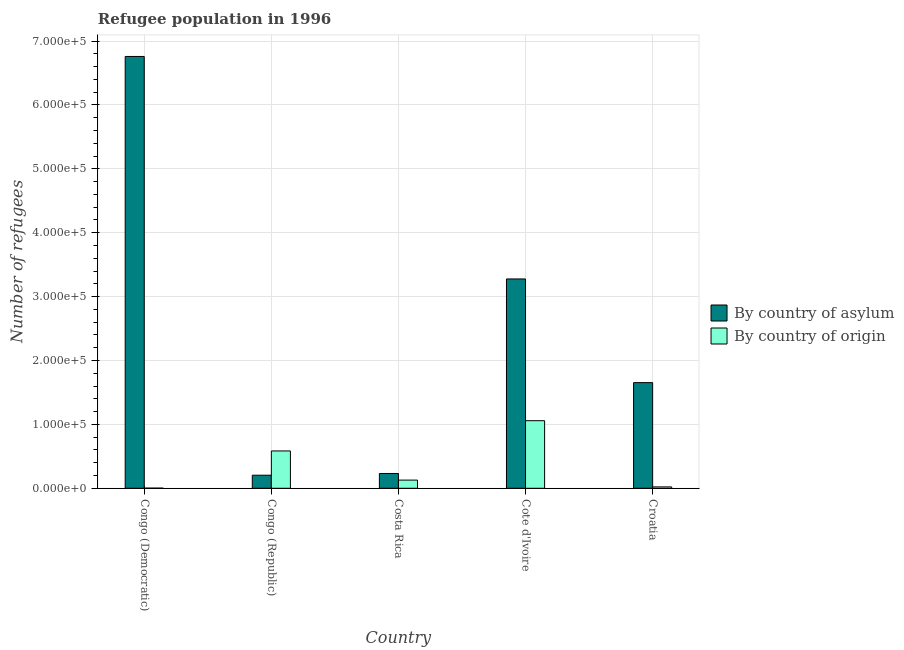How many groups of bars are there?
Offer a very short reply. 5. Are the number of bars on each tick of the X-axis equal?
Make the answer very short. Yes. How many bars are there on the 5th tick from the left?
Provide a short and direct response. 2. How many bars are there on the 1st tick from the right?
Offer a terse response. 2. What is the label of the 1st group of bars from the left?
Ensure brevity in your answer.  Congo (Democratic). In how many cases, is the number of bars for a given country not equal to the number of legend labels?
Give a very brief answer. 0. What is the number of refugees by country of asylum in Costa Rica?
Your response must be concise. 2.32e+04. Across all countries, what is the maximum number of refugees by country of origin?
Give a very brief answer. 1.06e+05. Across all countries, what is the minimum number of refugees by country of origin?
Offer a terse response. 240. In which country was the number of refugees by country of asylum maximum?
Give a very brief answer. Congo (Democratic). In which country was the number of refugees by country of origin minimum?
Keep it short and to the point. Congo (Democratic). What is the total number of refugees by country of asylum in the graph?
Your answer should be very brief. 1.21e+06. What is the difference between the number of refugees by country of origin in Congo (Republic) and that in Croatia?
Ensure brevity in your answer.  5.63e+04. What is the difference between the number of refugees by country of asylum in Congo (Republic) and the number of refugees by country of origin in Cote d'Ivoire?
Provide a succinct answer. -8.54e+04. What is the average number of refugees by country of origin per country?
Make the answer very short. 3.59e+04. What is the difference between the number of refugees by country of asylum and number of refugees by country of origin in Croatia?
Your answer should be compact. 1.63e+05. In how many countries, is the number of refugees by country of asylum greater than 300000 ?
Provide a short and direct response. 2. What is the ratio of the number of refugees by country of origin in Congo (Republic) to that in Croatia?
Offer a terse response. 26.96. Is the number of refugees by country of asylum in Congo (Democratic) less than that in Cote d'Ivoire?
Ensure brevity in your answer.  No. What is the difference between the highest and the second highest number of refugees by country of origin?
Offer a terse response. 4.74e+04. What is the difference between the highest and the lowest number of refugees by country of asylum?
Provide a succinct answer. 6.56e+05. In how many countries, is the number of refugees by country of origin greater than the average number of refugees by country of origin taken over all countries?
Offer a very short reply. 2. Is the sum of the number of refugees by country of origin in Congo (Democratic) and Congo (Republic) greater than the maximum number of refugees by country of asylum across all countries?
Make the answer very short. No. What does the 2nd bar from the left in Congo (Republic) represents?
Make the answer very short. By country of origin. What does the 2nd bar from the right in Croatia represents?
Ensure brevity in your answer.  By country of asylum. What is the difference between two consecutive major ticks on the Y-axis?
Give a very brief answer. 1.00e+05. How are the legend labels stacked?
Your answer should be very brief. Vertical. What is the title of the graph?
Make the answer very short. Refugee population in 1996. Does "Adolescent fertility rate" appear as one of the legend labels in the graph?
Provide a short and direct response. No. What is the label or title of the X-axis?
Your answer should be very brief. Country. What is the label or title of the Y-axis?
Ensure brevity in your answer.  Number of refugees. What is the Number of refugees in By country of asylum in Congo (Democratic)?
Offer a terse response. 6.76e+05. What is the Number of refugees in By country of origin in Congo (Democratic)?
Your answer should be very brief. 240. What is the Number of refugees in By country of asylum in Congo (Republic)?
Make the answer very short. 2.05e+04. What is the Number of refugees of By country of origin in Congo (Republic)?
Keep it short and to the point. 5.84e+04. What is the Number of refugees of By country of asylum in Costa Rica?
Provide a short and direct response. 2.32e+04. What is the Number of refugees of By country of origin in Costa Rica?
Offer a very short reply. 1.28e+04. What is the Number of refugees in By country of asylum in Cote d'Ivoire?
Provide a short and direct response. 3.28e+05. What is the Number of refugees in By country of origin in Cote d'Ivoire?
Your answer should be very brief. 1.06e+05. What is the Number of refugees of By country of asylum in Croatia?
Offer a very short reply. 1.65e+05. What is the Number of refugees of By country of origin in Croatia?
Offer a terse response. 2168. Across all countries, what is the maximum Number of refugees in By country of asylum?
Ensure brevity in your answer.  6.76e+05. Across all countries, what is the maximum Number of refugees of By country of origin?
Provide a short and direct response. 1.06e+05. Across all countries, what is the minimum Number of refugees of By country of asylum?
Offer a very short reply. 2.05e+04. Across all countries, what is the minimum Number of refugees in By country of origin?
Your answer should be compact. 240. What is the total Number of refugees in By country of asylum in the graph?
Give a very brief answer. 1.21e+06. What is the total Number of refugees in By country of origin in the graph?
Give a very brief answer. 1.79e+05. What is the difference between the Number of refugees in By country of asylum in Congo (Democratic) and that in Congo (Republic)?
Your answer should be compact. 6.56e+05. What is the difference between the Number of refugees of By country of origin in Congo (Democratic) and that in Congo (Republic)?
Your answer should be compact. -5.82e+04. What is the difference between the Number of refugees in By country of asylum in Congo (Democratic) and that in Costa Rica?
Ensure brevity in your answer.  6.53e+05. What is the difference between the Number of refugees in By country of origin in Congo (Democratic) and that in Costa Rica?
Your answer should be compact. -1.26e+04. What is the difference between the Number of refugees in By country of asylum in Congo (Democratic) and that in Cote d'Ivoire?
Provide a succinct answer. 3.48e+05. What is the difference between the Number of refugees in By country of origin in Congo (Democratic) and that in Cote d'Ivoire?
Ensure brevity in your answer.  -1.06e+05. What is the difference between the Number of refugees in By country of asylum in Congo (Democratic) and that in Croatia?
Your answer should be compact. 5.11e+05. What is the difference between the Number of refugees in By country of origin in Congo (Democratic) and that in Croatia?
Your response must be concise. -1928. What is the difference between the Number of refugees in By country of asylum in Congo (Republic) and that in Costa Rica?
Your answer should be very brief. -2725. What is the difference between the Number of refugees in By country of origin in Congo (Republic) and that in Costa Rica?
Ensure brevity in your answer.  4.56e+04. What is the difference between the Number of refugees in By country of asylum in Congo (Republic) and that in Cote d'Ivoire?
Make the answer very short. -3.07e+05. What is the difference between the Number of refugees in By country of origin in Congo (Republic) and that in Cote d'Ivoire?
Your response must be concise. -4.74e+04. What is the difference between the Number of refugees in By country of asylum in Congo (Republic) and that in Croatia?
Your answer should be compact. -1.45e+05. What is the difference between the Number of refugees in By country of origin in Congo (Republic) and that in Croatia?
Your answer should be compact. 5.63e+04. What is the difference between the Number of refugees of By country of asylum in Costa Rica and that in Cote d'Ivoire?
Provide a succinct answer. -3.05e+05. What is the difference between the Number of refugees of By country of origin in Costa Rica and that in Cote d'Ivoire?
Ensure brevity in your answer.  -9.30e+04. What is the difference between the Number of refugees in By country of asylum in Costa Rica and that in Croatia?
Offer a very short reply. -1.42e+05. What is the difference between the Number of refugees in By country of origin in Costa Rica and that in Croatia?
Offer a terse response. 1.06e+04. What is the difference between the Number of refugees of By country of asylum in Cote d'Ivoire and that in Croatia?
Offer a very short reply. 1.62e+05. What is the difference between the Number of refugees of By country of origin in Cote d'Ivoire and that in Croatia?
Ensure brevity in your answer.  1.04e+05. What is the difference between the Number of refugees of By country of asylum in Congo (Democratic) and the Number of refugees of By country of origin in Congo (Republic)?
Give a very brief answer. 6.18e+05. What is the difference between the Number of refugees of By country of asylum in Congo (Democratic) and the Number of refugees of By country of origin in Costa Rica?
Keep it short and to the point. 6.63e+05. What is the difference between the Number of refugees of By country of asylum in Congo (Democratic) and the Number of refugees of By country of origin in Cote d'Ivoire?
Your response must be concise. 5.70e+05. What is the difference between the Number of refugees in By country of asylum in Congo (Democratic) and the Number of refugees in By country of origin in Croatia?
Offer a terse response. 6.74e+05. What is the difference between the Number of refugees of By country of asylum in Congo (Republic) and the Number of refugees of By country of origin in Costa Rica?
Ensure brevity in your answer.  7646. What is the difference between the Number of refugees in By country of asylum in Congo (Republic) and the Number of refugees in By country of origin in Cote d'Ivoire?
Your answer should be compact. -8.54e+04. What is the difference between the Number of refugees in By country of asylum in Congo (Republic) and the Number of refugees in By country of origin in Croatia?
Offer a very short reply. 1.83e+04. What is the difference between the Number of refugees in By country of asylum in Costa Rica and the Number of refugees in By country of origin in Cote d'Ivoire?
Offer a very short reply. -8.26e+04. What is the difference between the Number of refugees of By country of asylum in Costa Rica and the Number of refugees of By country of origin in Croatia?
Keep it short and to the point. 2.10e+04. What is the difference between the Number of refugees of By country of asylum in Cote d'Ivoire and the Number of refugees of By country of origin in Croatia?
Make the answer very short. 3.26e+05. What is the average Number of refugees of By country of asylum per country?
Your answer should be compact. 2.43e+05. What is the average Number of refugees of By country of origin per country?
Make the answer very short. 3.59e+04. What is the difference between the Number of refugees of By country of asylum and Number of refugees of By country of origin in Congo (Democratic)?
Give a very brief answer. 6.76e+05. What is the difference between the Number of refugees in By country of asylum and Number of refugees in By country of origin in Congo (Republic)?
Your response must be concise. -3.80e+04. What is the difference between the Number of refugees of By country of asylum and Number of refugees of By country of origin in Costa Rica?
Your answer should be very brief. 1.04e+04. What is the difference between the Number of refugees of By country of asylum and Number of refugees of By country of origin in Cote d'Ivoire?
Provide a succinct answer. 2.22e+05. What is the difference between the Number of refugees of By country of asylum and Number of refugees of By country of origin in Croatia?
Ensure brevity in your answer.  1.63e+05. What is the ratio of the Number of refugees in By country of asylum in Congo (Democratic) to that in Congo (Republic)?
Provide a succinct answer. 33.05. What is the ratio of the Number of refugees of By country of origin in Congo (Democratic) to that in Congo (Republic)?
Your answer should be very brief. 0. What is the ratio of the Number of refugees in By country of asylum in Congo (Democratic) to that in Costa Rica?
Provide a short and direct response. 29.17. What is the ratio of the Number of refugees of By country of origin in Congo (Democratic) to that in Costa Rica?
Make the answer very short. 0.02. What is the ratio of the Number of refugees of By country of asylum in Congo (Democratic) to that in Cote d'Ivoire?
Offer a very short reply. 2.06. What is the ratio of the Number of refugees of By country of origin in Congo (Democratic) to that in Cote d'Ivoire?
Your answer should be very brief. 0. What is the ratio of the Number of refugees in By country of asylum in Congo (Democratic) to that in Croatia?
Your answer should be compact. 4.09. What is the ratio of the Number of refugees in By country of origin in Congo (Democratic) to that in Croatia?
Make the answer very short. 0.11. What is the ratio of the Number of refugees in By country of asylum in Congo (Republic) to that in Costa Rica?
Make the answer very short. 0.88. What is the ratio of the Number of refugees in By country of origin in Congo (Republic) to that in Costa Rica?
Ensure brevity in your answer.  4.56. What is the ratio of the Number of refugees in By country of asylum in Congo (Republic) to that in Cote d'Ivoire?
Give a very brief answer. 0.06. What is the ratio of the Number of refugees of By country of origin in Congo (Republic) to that in Cote d'Ivoire?
Make the answer very short. 0.55. What is the ratio of the Number of refugees of By country of asylum in Congo (Republic) to that in Croatia?
Your answer should be compact. 0.12. What is the ratio of the Number of refugees in By country of origin in Congo (Republic) to that in Croatia?
Your response must be concise. 26.96. What is the ratio of the Number of refugees in By country of asylum in Costa Rica to that in Cote d'Ivoire?
Keep it short and to the point. 0.07. What is the ratio of the Number of refugees of By country of origin in Costa Rica to that in Cote d'Ivoire?
Provide a succinct answer. 0.12. What is the ratio of the Number of refugees in By country of asylum in Costa Rica to that in Croatia?
Offer a very short reply. 0.14. What is the ratio of the Number of refugees in By country of origin in Costa Rica to that in Croatia?
Give a very brief answer. 5.91. What is the ratio of the Number of refugees in By country of asylum in Cote d'Ivoire to that in Croatia?
Your answer should be very brief. 1.98. What is the ratio of the Number of refugees in By country of origin in Cote d'Ivoire to that in Croatia?
Provide a succinct answer. 48.81. What is the difference between the highest and the second highest Number of refugees in By country of asylum?
Your response must be concise. 3.48e+05. What is the difference between the highest and the second highest Number of refugees of By country of origin?
Offer a terse response. 4.74e+04. What is the difference between the highest and the lowest Number of refugees of By country of asylum?
Give a very brief answer. 6.56e+05. What is the difference between the highest and the lowest Number of refugees in By country of origin?
Keep it short and to the point. 1.06e+05. 